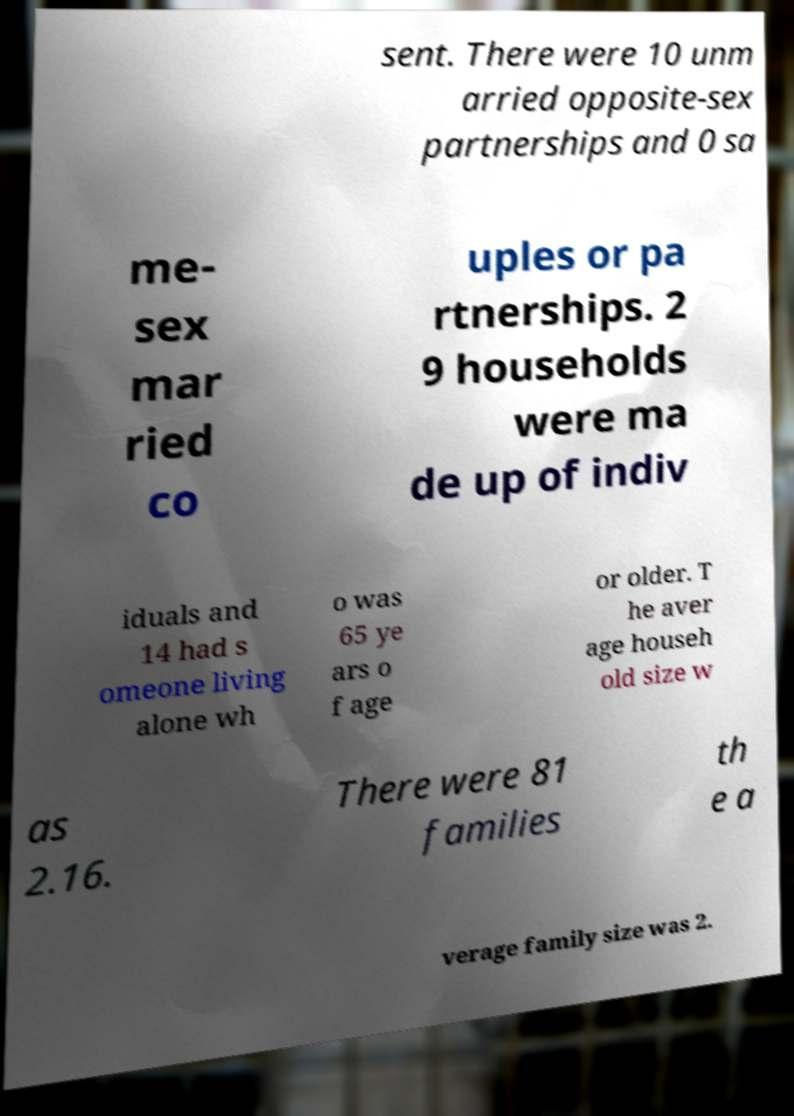Please identify and transcribe the text found in this image. sent. There were 10 unm arried opposite-sex partnerships and 0 sa me- sex mar ried co uples or pa rtnerships. 2 9 households were ma de up of indiv iduals and 14 had s omeone living alone wh o was 65 ye ars o f age or older. T he aver age househ old size w as 2.16. There were 81 families th e a verage family size was 2. 